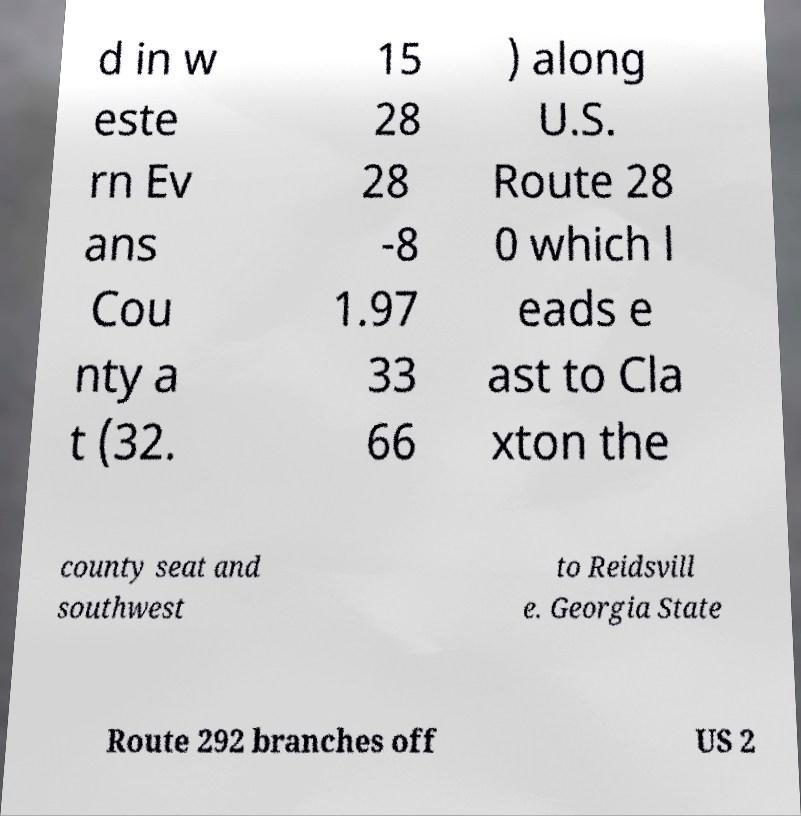Can you accurately transcribe the text from the provided image for me? d in w este rn Ev ans Cou nty a t (32. 15 28 28 -8 1.97 33 66 ) along U.S. Route 28 0 which l eads e ast to Cla xton the county seat and southwest to Reidsvill e. Georgia State Route 292 branches off US 2 